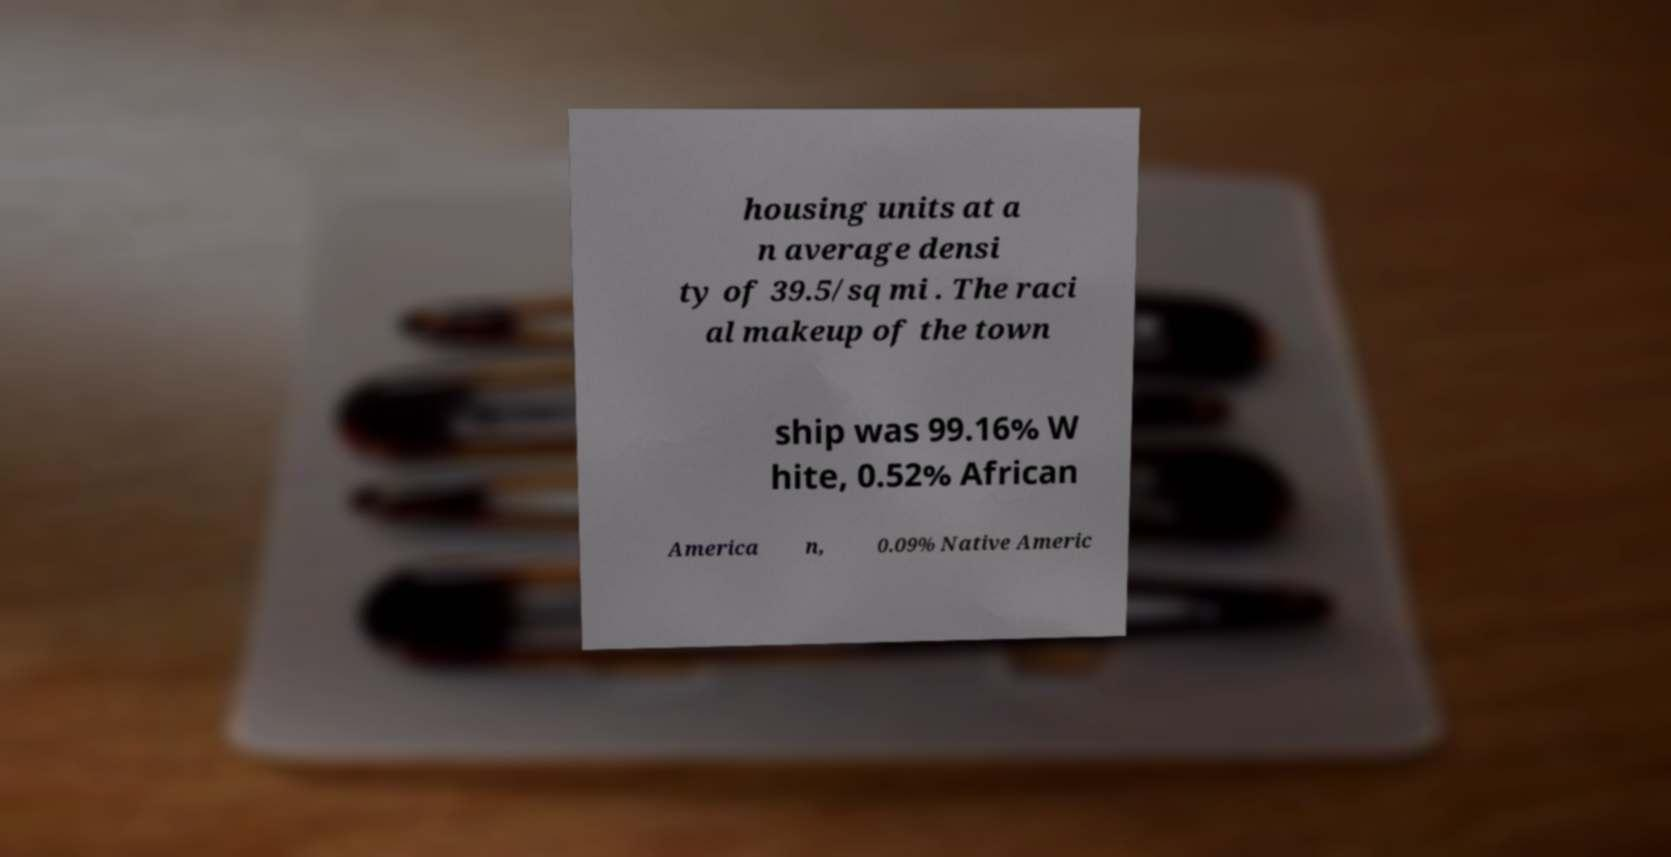What messages or text are displayed in this image? I need them in a readable, typed format. housing units at a n average densi ty of 39.5/sq mi . The raci al makeup of the town ship was 99.16% W hite, 0.52% African America n, 0.09% Native Americ 